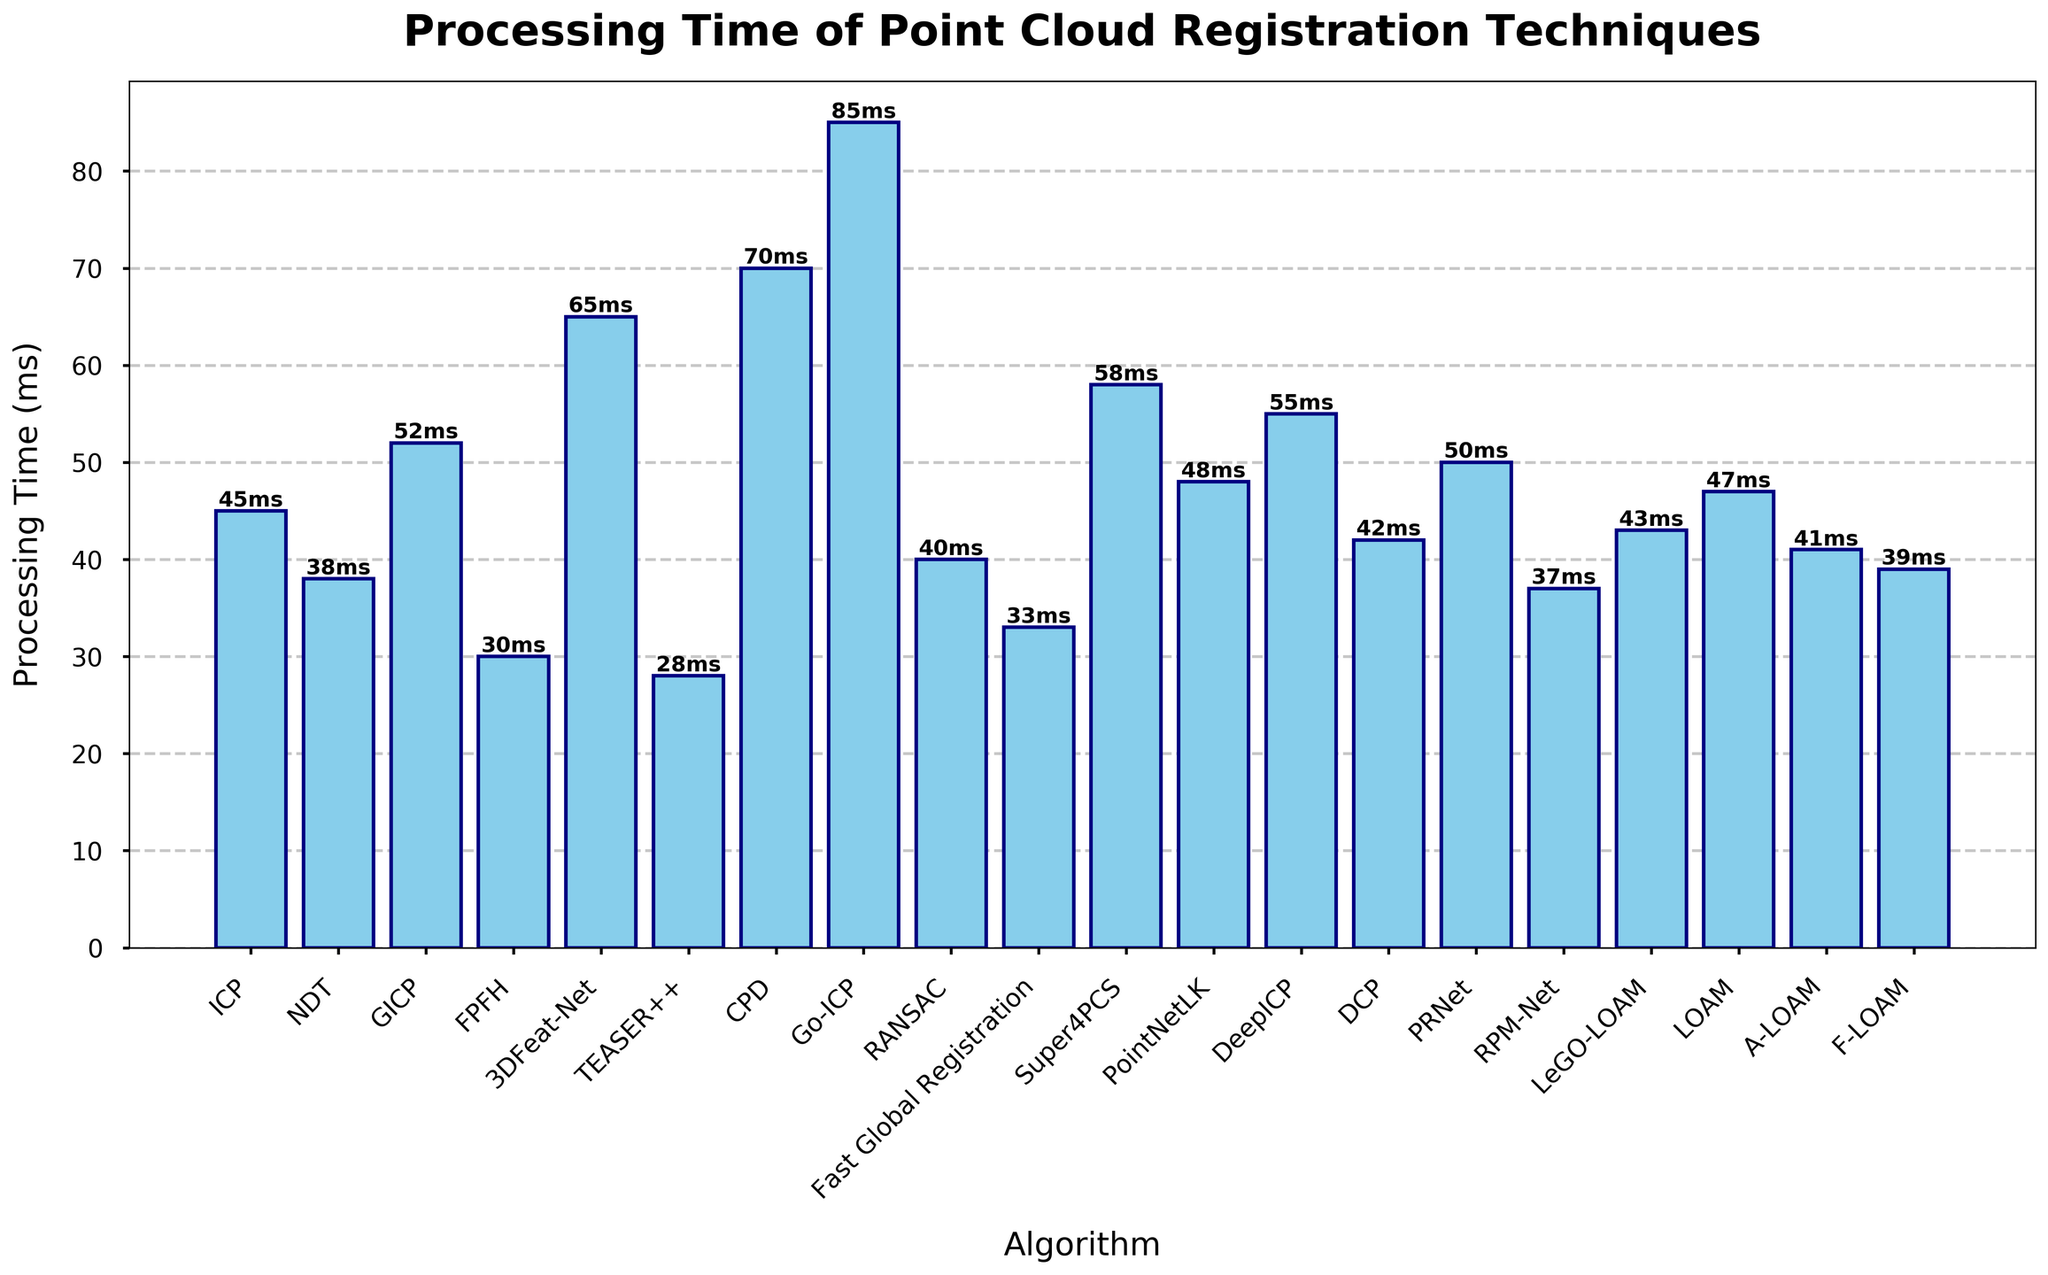Which algorithm has the shortest processing time? To find the shortest processing time, look for the smallest bar in the chart. TEASER++ has the smallest bar with 28 ms processing time.
Answer: TEASER++ What is the processing time difference between Go-ICP and FPFH? Find the heights of the bars for Go-ICP and FPFH, which are 85 ms and 30 ms respectively. Subtract the smaller value from the larger value: 85 - 30 = 55 ms.
Answer: 55 ms Which algorithm has a processing time very close to 40ms? Look for the bars with values near 40 ms. RANSAC has a processing time of 40 ms, and A-LOAM has 41 ms. The closest is RANSAC.
Answer: RANSAC What is the average processing time of the five fastest algorithms? Identify the five algorithms with the smallest bars: TEASER++ (28 ms), FPFH (30 ms), RPM-Net (37 ms), NDT (38 ms), and F-LOAM (39 ms). Calculate the average: (28 + 30 + 37 + 38 + 39)/5 = 34.4 ms.
Answer: 34.4 ms How many algorithms have a processing time greater than 50 ms? Count the number of bars exceeding the 50 ms mark. These are GICP (52 ms), 3DFeat-Net (65 ms), CPD (70 ms), Super4PCS (58 ms), DeepICP (55 ms), PRNet (50 ms). There are 6 such algorithms.
Answer: 6 Which algorithms have processing times that are exactly 48 ms and 47 ms? Find the bars at 48 ms and 47 ms. PointNetLK is 48 ms and LOAM is 47 ms.
Answer: PointNetLK and LOAM Which algorithm shows a processing time higher than RPM-Net but lower than Fast Global Registration? RPM-Net is 37 ms, Fast Global Registration is 33 ms. The algorithm between these times in ascending order is Fast Global Registration at 33 ms.
Answer: Fast Global Registration What is the processing time difference between the fastest and the slowest algorithms? Identify the fastest (TEASER++, 28 ms) and the slowest (Go-ICP, 85 ms). Calculate the difference: 85 - 28 = 57 ms.
Answer: 57 ms What is the combined processing time of the top three slowest algorithms? Identify the top three slowest: Go-ICP (85 ms), CPD (70 ms), and 3DFeat-Net (65 ms). Sum them: 85 + 70 + 65 = 220 ms.
Answer: 220 ms 